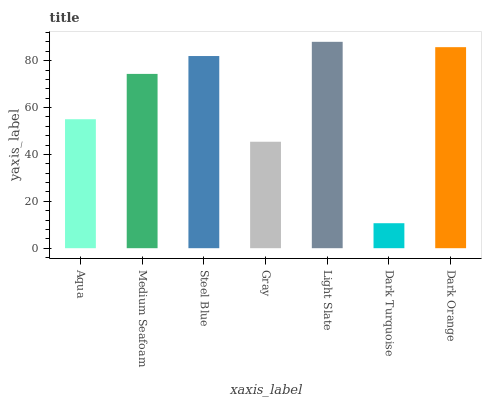Is Dark Turquoise the minimum?
Answer yes or no. Yes. Is Light Slate the maximum?
Answer yes or no. Yes. Is Medium Seafoam the minimum?
Answer yes or no. No. Is Medium Seafoam the maximum?
Answer yes or no. No. Is Medium Seafoam greater than Aqua?
Answer yes or no. Yes. Is Aqua less than Medium Seafoam?
Answer yes or no. Yes. Is Aqua greater than Medium Seafoam?
Answer yes or no. No. Is Medium Seafoam less than Aqua?
Answer yes or no. No. Is Medium Seafoam the high median?
Answer yes or no. Yes. Is Medium Seafoam the low median?
Answer yes or no. Yes. Is Light Slate the high median?
Answer yes or no. No. Is Gray the low median?
Answer yes or no. No. 